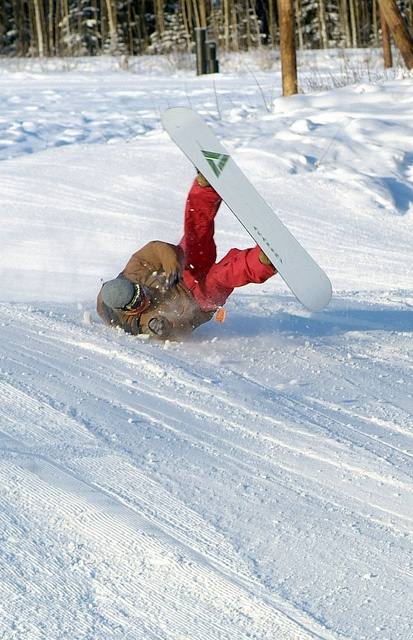Describe the objects in this image and their specific colors. I can see people in black, maroon, gray, and brown tones and snowboard in black, lightgray, and darkgray tones in this image. 